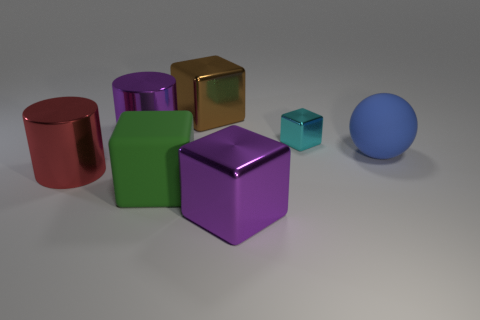Add 1 gray cubes. How many objects exist? 8 Subtract all blocks. How many objects are left? 3 Add 1 blue spheres. How many blue spheres exist? 2 Subtract 0 red cubes. How many objects are left? 7 Subtract all big matte spheres. Subtract all big red cylinders. How many objects are left? 5 Add 7 tiny cyan metallic cubes. How many tiny cyan metallic cubes are left? 8 